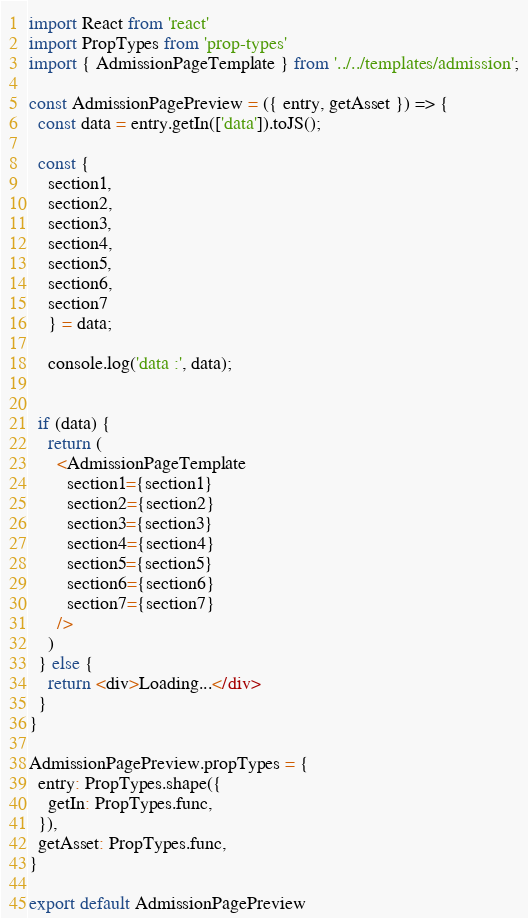Convert code to text. <code><loc_0><loc_0><loc_500><loc_500><_JavaScript_>import React from 'react'
import PropTypes from 'prop-types'
import { AdmissionPageTemplate } from '../../templates/admission';

const AdmissionPagePreview = ({ entry, getAsset }) => {
  const data = entry.getIn(['data']).toJS();

  const { 
    section1, 
    section2, 
    section3, 
    section4, 
    section5, 
    section6,
    section7
    } = data;

    console.log('data :', data);


  if (data) {
    return (
      <AdmissionPageTemplate
        section1={section1}
        section2={section2}
        section3={section3}
        section4={section4} 
        section5={section5} 
        section6={section6} 
        section7={section7}
      />
    )
  } else {
    return <div>Loading...</div>
  }
}

AdmissionPagePreview.propTypes = {
  entry: PropTypes.shape({
    getIn: PropTypes.func,
  }),
  getAsset: PropTypes.func,
}

export default AdmissionPagePreview
</code> 